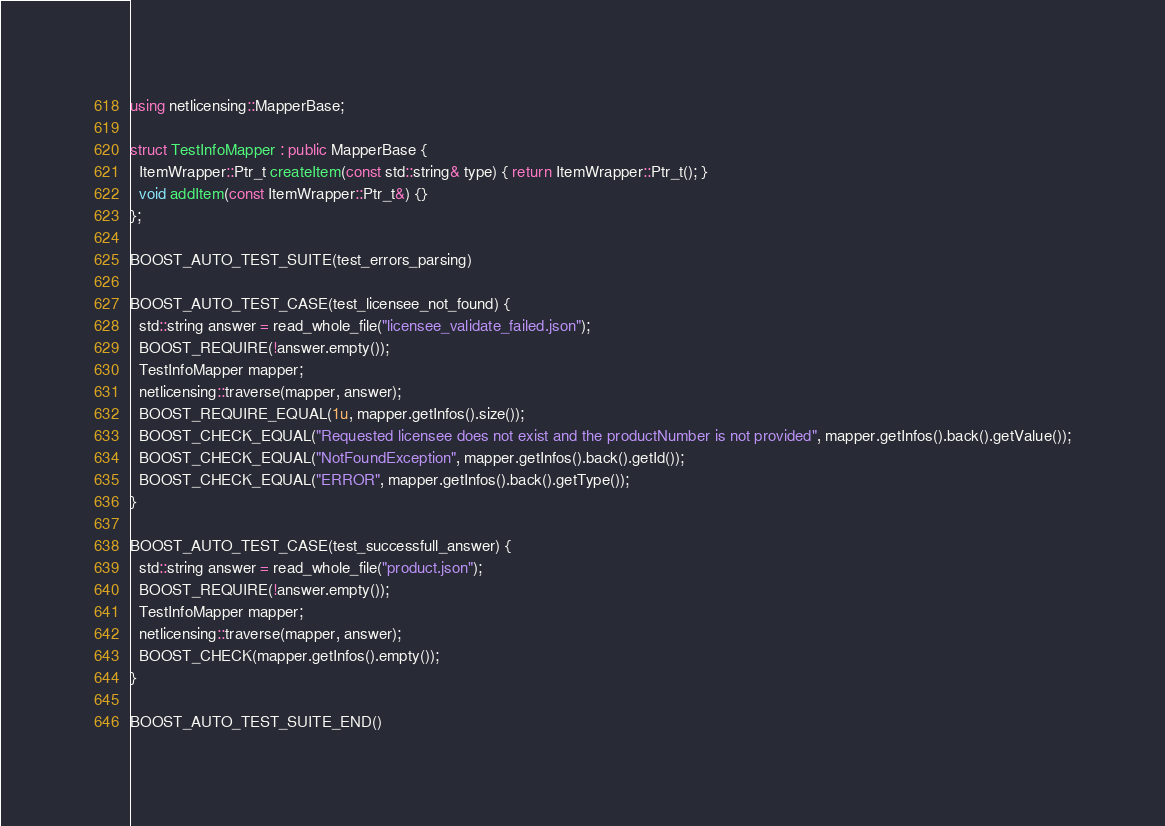<code> <loc_0><loc_0><loc_500><loc_500><_C++_>using netlicensing::MapperBase;

struct TestInfoMapper : public MapperBase {
  ItemWrapper::Ptr_t createItem(const std::string& type) { return ItemWrapper::Ptr_t(); }
  void addItem(const ItemWrapper::Ptr_t&) {}
};

BOOST_AUTO_TEST_SUITE(test_errors_parsing)

BOOST_AUTO_TEST_CASE(test_licensee_not_found) {
  std::string answer = read_whole_file("licensee_validate_failed.json");
  BOOST_REQUIRE(!answer.empty());
  TestInfoMapper mapper;
  netlicensing::traverse(mapper, answer);
  BOOST_REQUIRE_EQUAL(1u, mapper.getInfos().size());
  BOOST_CHECK_EQUAL("Requested licensee does not exist and the productNumber is not provided", mapper.getInfos().back().getValue());
  BOOST_CHECK_EQUAL("NotFoundException", mapper.getInfos().back().getId());
  BOOST_CHECK_EQUAL("ERROR", mapper.getInfos().back().getType());
}

BOOST_AUTO_TEST_CASE(test_successfull_answer) {
  std::string answer = read_whole_file("product.json");
  BOOST_REQUIRE(!answer.empty());
  TestInfoMapper mapper;
  netlicensing::traverse(mapper, answer);
  BOOST_CHECK(mapper.getInfos().empty());
}

BOOST_AUTO_TEST_SUITE_END()
</code> 